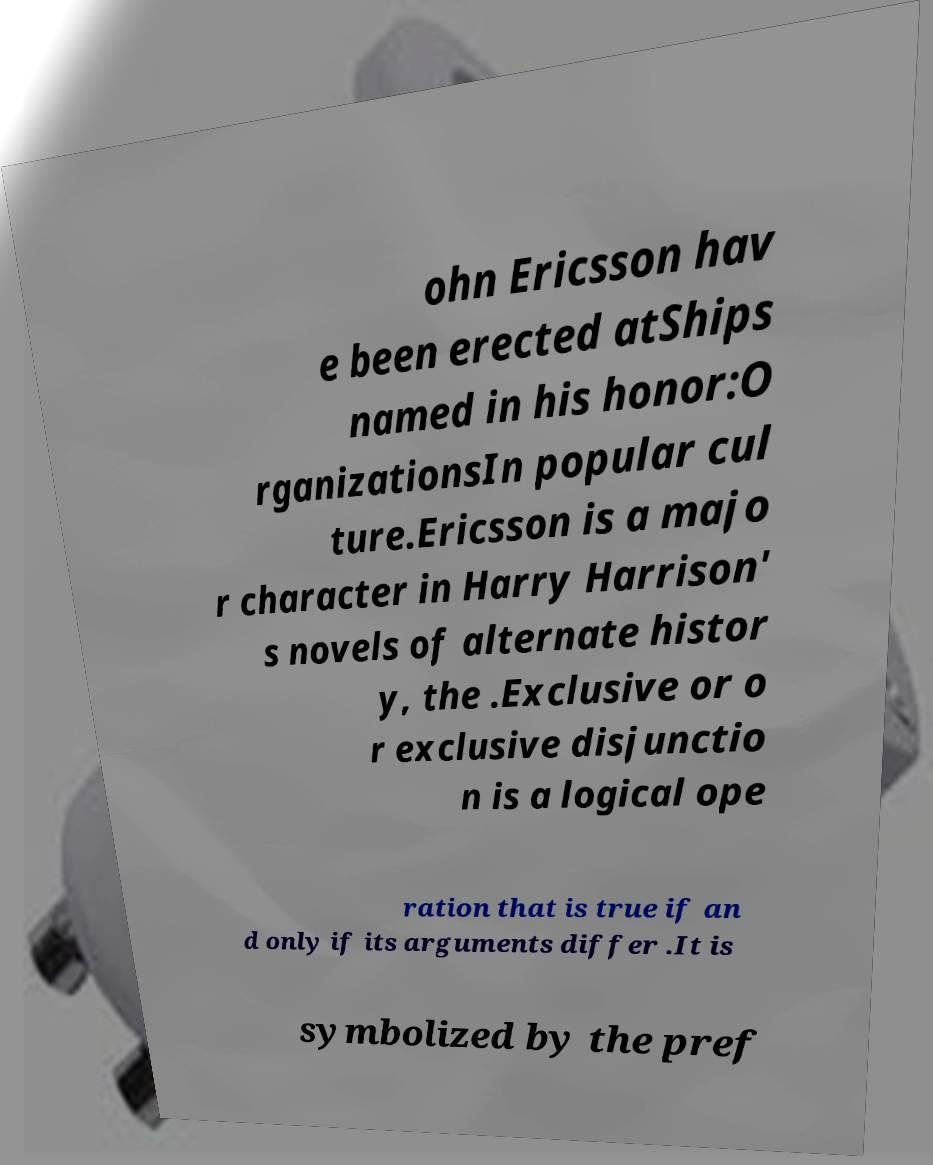Can you read and provide the text displayed in the image?This photo seems to have some interesting text. Can you extract and type it out for me? ohn Ericsson hav e been erected atShips named in his honor:O rganizationsIn popular cul ture.Ericsson is a majo r character in Harry Harrison' s novels of alternate histor y, the .Exclusive or o r exclusive disjunctio n is a logical ope ration that is true if an d only if its arguments differ .It is symbolized by the pref 